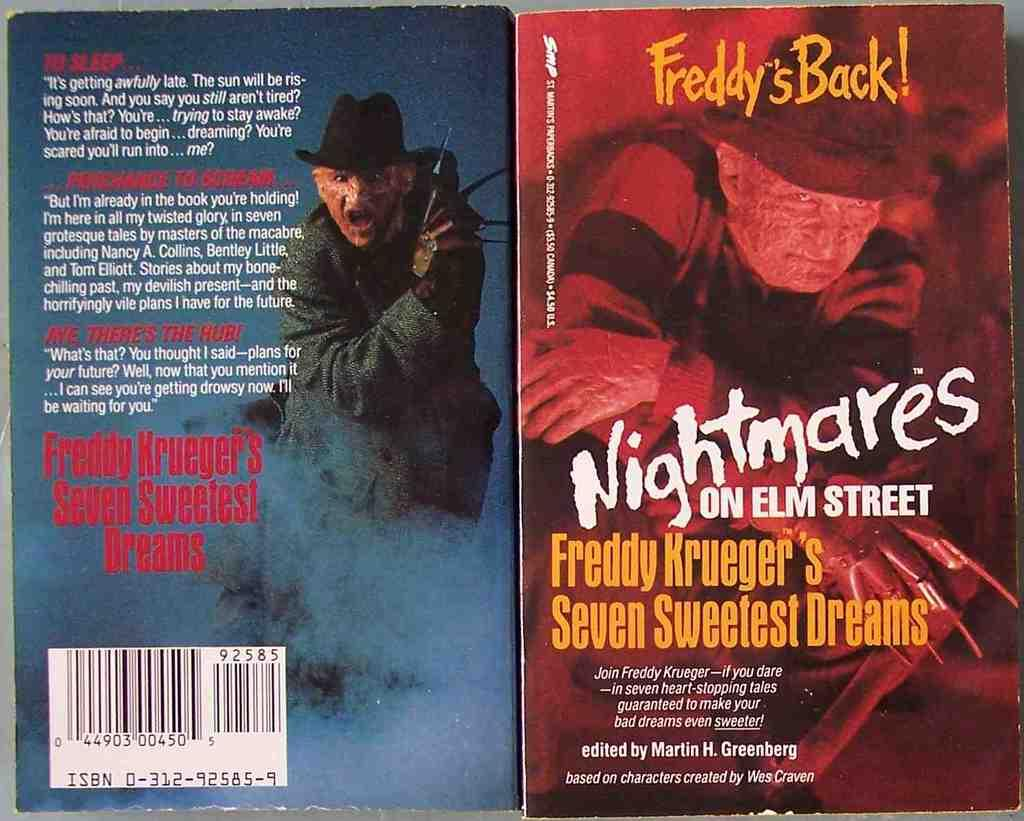<image>
Relay a brief, clear account of the picture shown. two books about Freddy Krueger including Seven Sweetest Dreams 